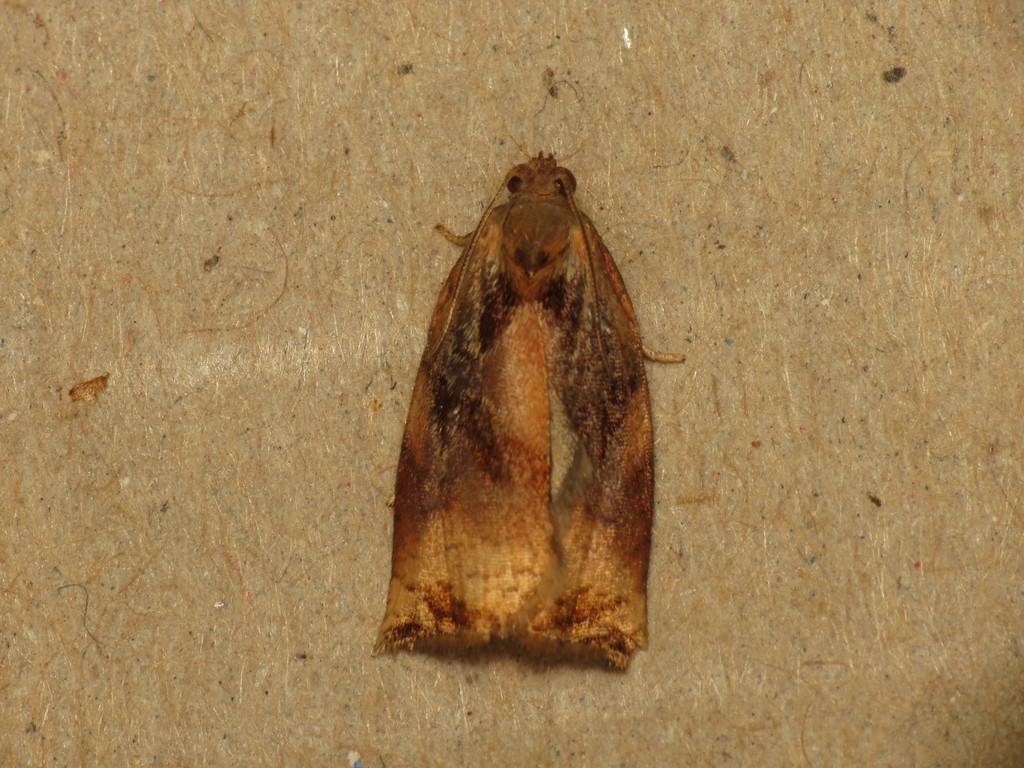Can you describe this image briefly? In this image we can see an insect on a wooden platform. 